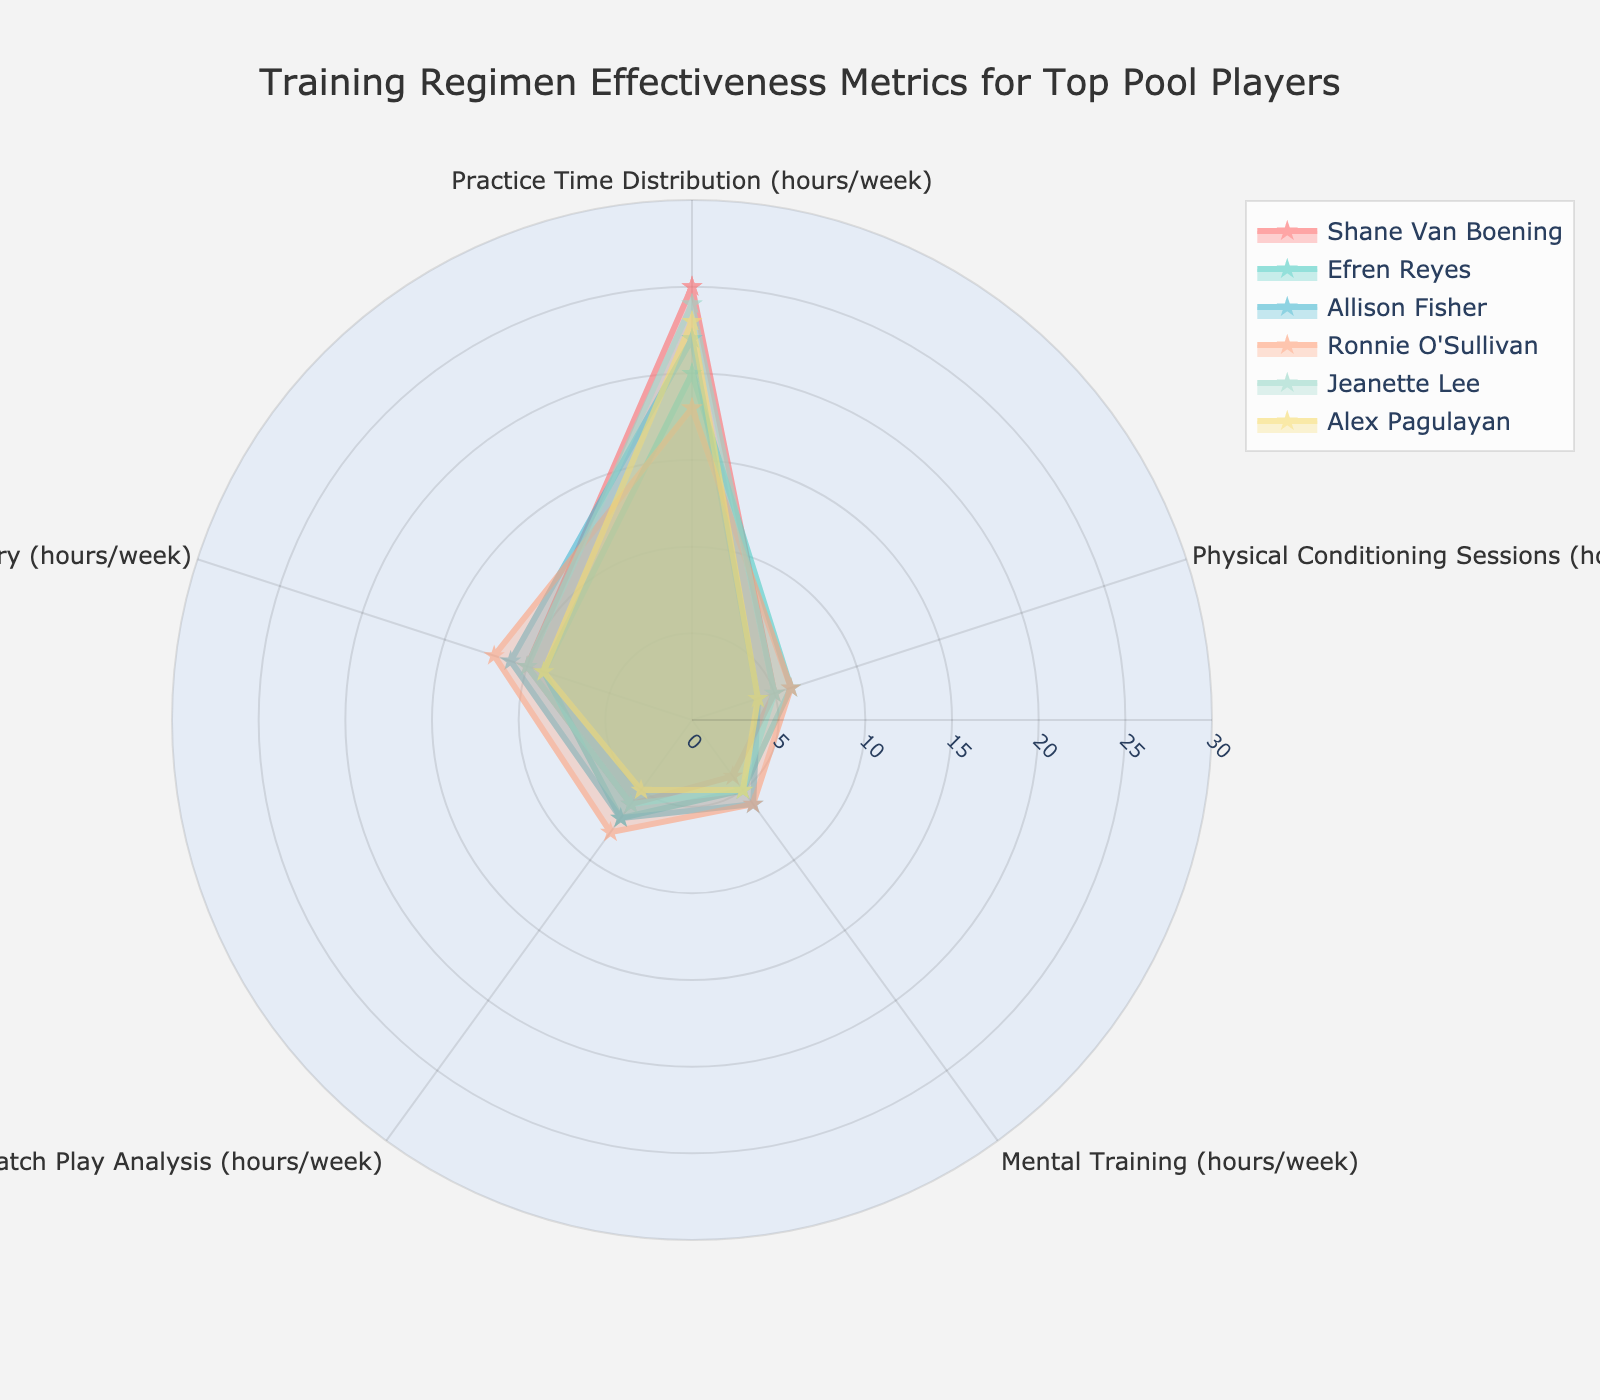What is the title of the figure? The title is usually placed at the top of the figure and describes what the figure represents. In this case, the title is "Training Regimen Effectiveness Metrics for Top Pool Players."
Answer: Training Regimen Effectiveness Metrics for Top Pool Players How many categories are used to evaluate the training regimen of the players? Each axis on the radar chart represents a category. Here, the categories are "Practice Time Distribution (hours/week)," "Physical Conditioning Sessions (hours/week)," "Mental Training (hours/week)," "Match Play Analysis (hours/week)," and "Rest and Recovery (hours/week)."
Answer: 5 Which player has the highest total training regimen hours per week? To determine the total training regimen hours per week, sum the hours for each category (ignoring redundancy). Shane Van Boening has the highest total (25 + 5 + 4 + 6 + 10 = 50).
Answer: Shane Van Boening Who spends the most time on mental training? Look at the data for "Mental Training (hours/week)" and find the highest value. Ronnie O'Sullivan and Allison Fisher both spend the most time, with 6 hours each.
Answer: Ronnie O'Sullivan and Allison Fisher What is the range of hours for practice time distribution among the players? The practice time distribution ranges from the highest value (Shane Van Boening with 25 hours) to the lowest value (Ronnie O'Sullivan with 18 hours). The range is 25 - 18 = 7 hours.
Answer: 7 hours Who has the most balanced training regimen? A balanced training regimen would show similar values across different categories on the radar chart. Visually, look for the player whose radar plot appears the most regular and evenly distributed.
Answer: Jeanette Lee Which player allocates the least time for rest and recovery? Find the player with the lowest value in the "Rest and Recovery (hours/week)" category. Alex Pagulayan spends the least time with 9 hours.
Answer: Alex Pagulayan Compare the time spent on physical conditioning by Efren Reyes and Alex Pagulayan. Who spends more, and by how many hours? Efren Reyes spends 6 hours, while Alex Pagulayan spends 4 hours on physical conditioning. The difference is 6 - 4 = 2 hours.
Answer: Efren Reyes by 2 hours Which player spends more hours on match play analysis: Shane Van Boening or Ronnie O'Sullivan? Look at the data for "Match Play Analysis (hours/week)" and compare the values for Shane Van Boening (6 hours) and Ronnie O'Sullivan (8 hours). Ronnie O'Sullivan spends more time.
Answer: Ronnie O'Sullivan What is the average time spent by all players on practice time distribution? Sum the practice time distribution hours for all players and divide by the number of players. (25 + 20 + 22 + 18 + 24 + 23) / 6 = 132 / 6 = 22 hours.
Answer: 22 hours 